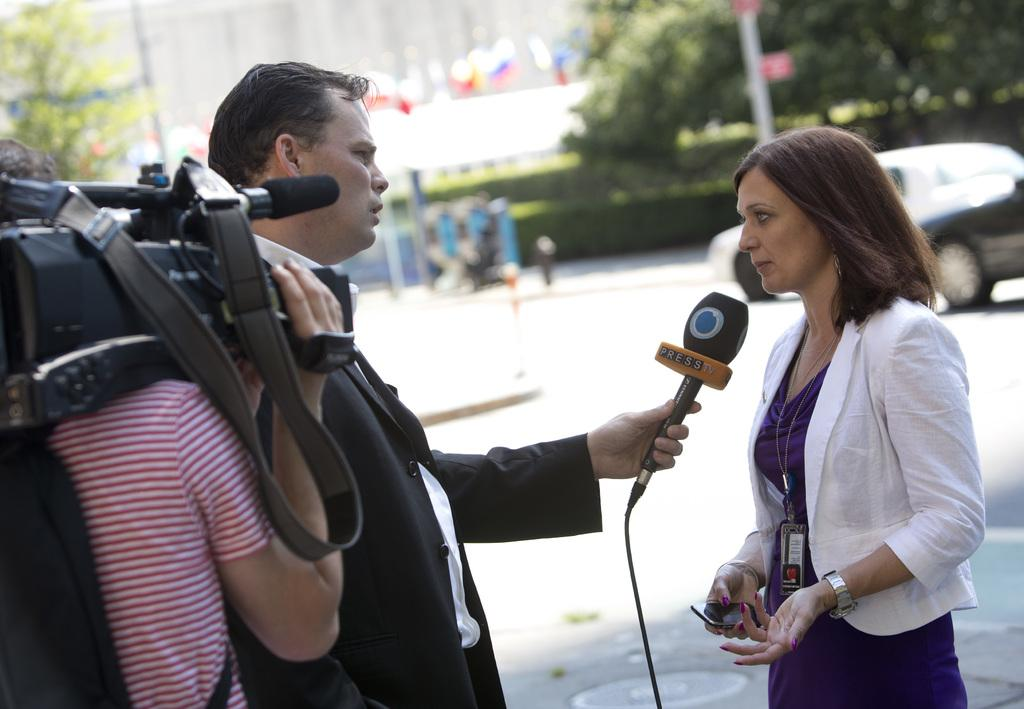How many people are in the image? There are three people in the image: a man and two women. What is the man holding in the image? The man is holding a microphone. What is one of the women holding in the image? One woman is holding a camera. What can be seen in the background of the image? There is a tree and a building in the background of the image. What language is the man speaking in the image? The image does not provide any information about the language being spoken. How does the digestion process of the tree in the background look like? The image does not provide any information about the digestion process of the tree; it only shows the tree as a background element. 